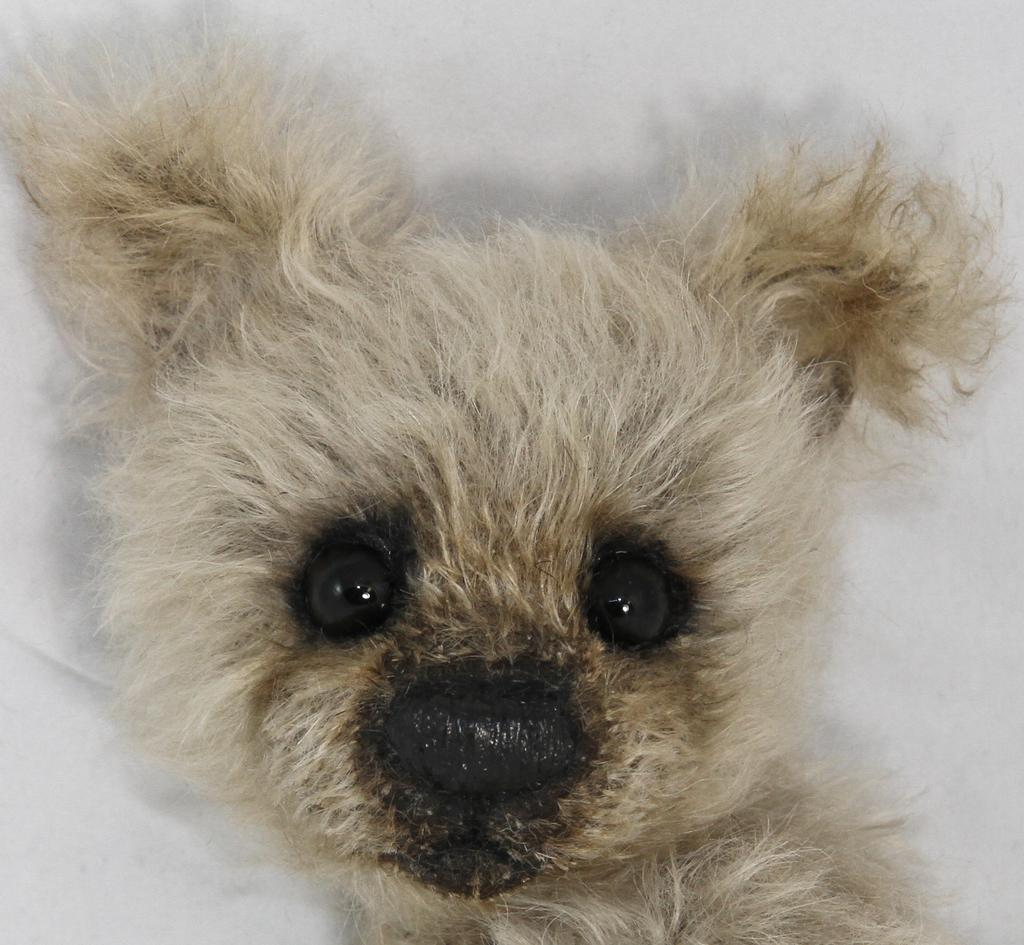What type of animal is present in the image? There is a dog in the image. What type of chain is the dog holding in the image? There is no chain present in the image; only the dog is visible. 